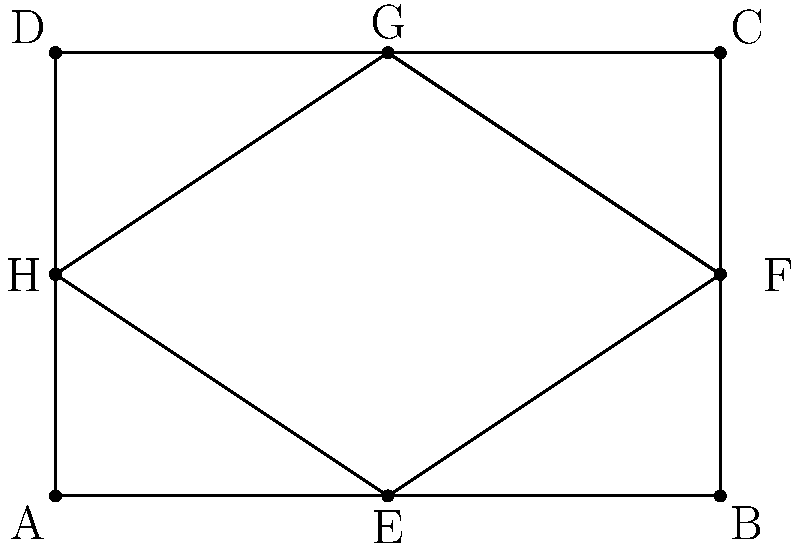In your community garden in Minnetonka, you're planning two flower beds: a rectangular bed ABCD and a rhombus-shaped bed EFGH, as shown in the diagram. If the area of rectangle ABCD is 24 square meters and EF = 5 meters, what is the area of rhombus EFGH? Let's approach this step-by-step:

1) First, we need to understand the properties of congruent polygons. Congruent polygons have the same shape and size, meaning all corresponding sides and angles are equal.

2) From the diagram, we can see that the diagonals of the rhombus (EG and HF) divide the rectangle into four congruent triangles.

3) The area of the rectangle ABCD is given as 24 square meters. Let's find its dimensions:
   Area of rectangle = length × width
   24 = 6 × 4 (from the diagram, we can see the length is 1.5 times the width)
   So, AB = 6m and AD = 4m

4) The diagonals of the rhombus are equal to the sides of the rectangle:
   EG = AB = 6m
   HF = AD = 4m

5) The area of a rhombus is given by the formula: 
   Area of rhombus = $\frac{1}{2}$ × (diagonal 1) × (diagonal 2)

6) Substituting the values:
   Area of rhombus EFGH = $\frac{1}{2}$ × 6 × 4 = 12 square meters

7) We can verify this result:
   Area of rhombus = Area of rectangle × $\frac{1}{2}$
                   = 24 × $\frac{1}{2}$ = 12 square meters

Therefore, the area of rhombus EFGH is 12 square meters.
Answer: 12 square meters 